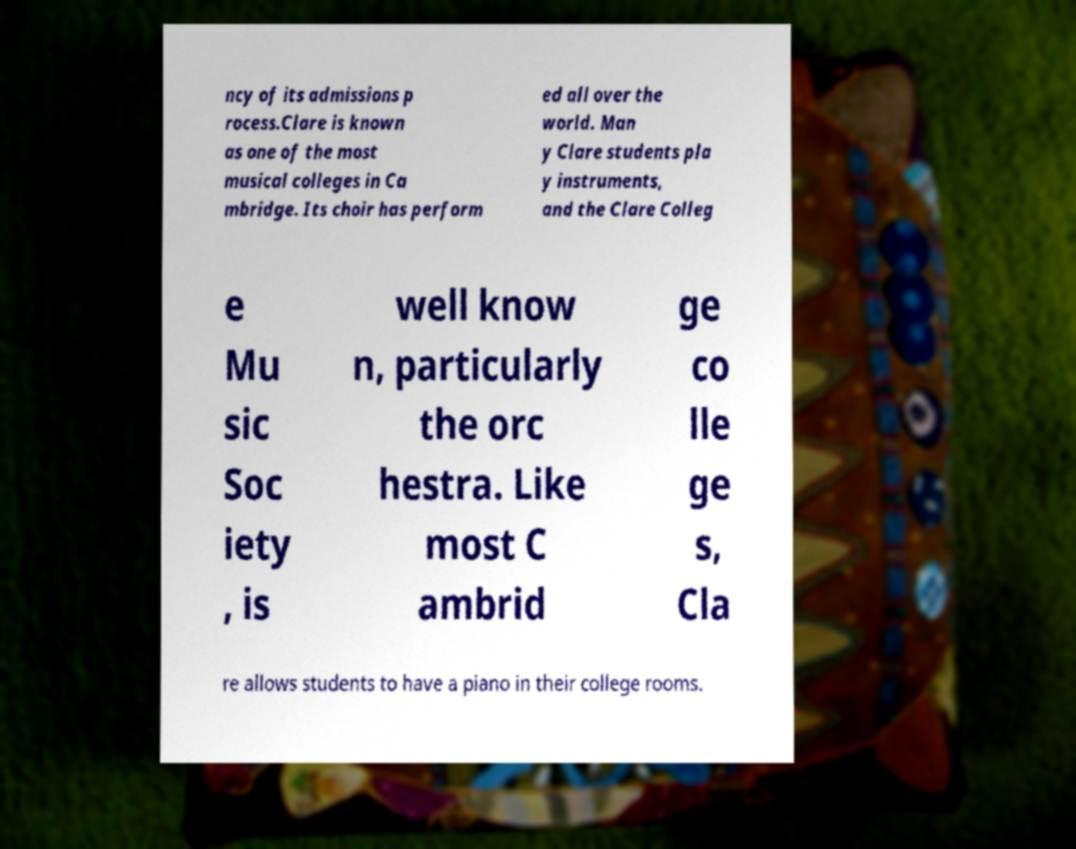Can you read and provide the text displayed in the image?This photo seems to have some interesting text. Can you extract and type it out for me? ncy of its admissions p rocess.Clare is known as one of the most musical colleges in Ca mbridge. Its choir has perform ed all over the world. Man y Clare students pla y instruments, and the Clare Colleg e Mu sic Soc iety , is well know n, particularly the orc hestra. Like most C ambrid ge co lle ge s, Cla re allows students to have a piano in their college rooms. 